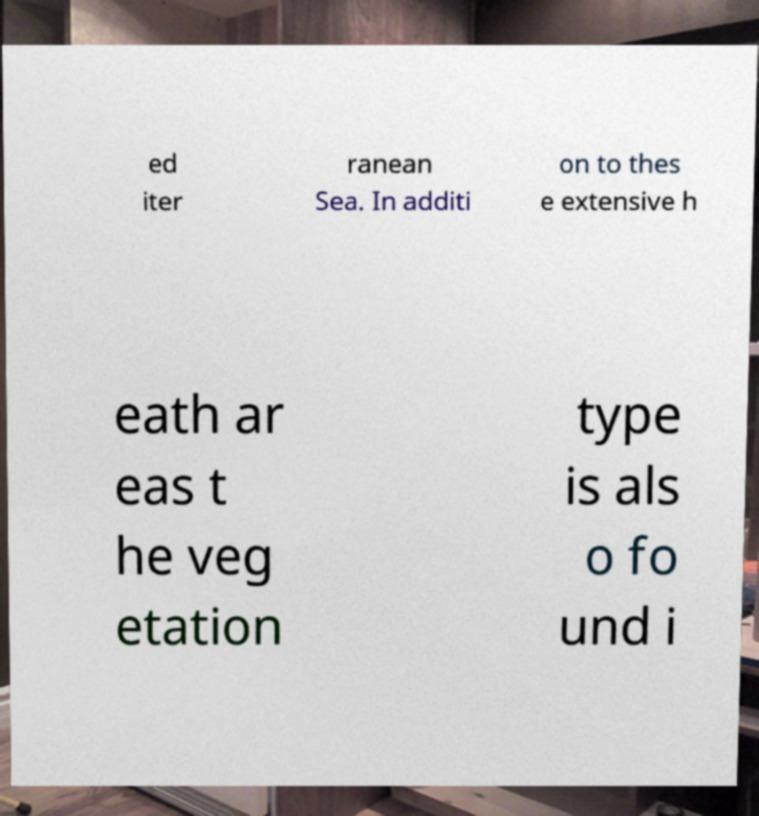Can you read and provide the text displayed in the image?This photo seems to have some interesting text. Can you extract and type it out for me? ed iter ranean Sea. In additi on to thes e extensive h eath ar eas t he veg etation type is als o fo und i 